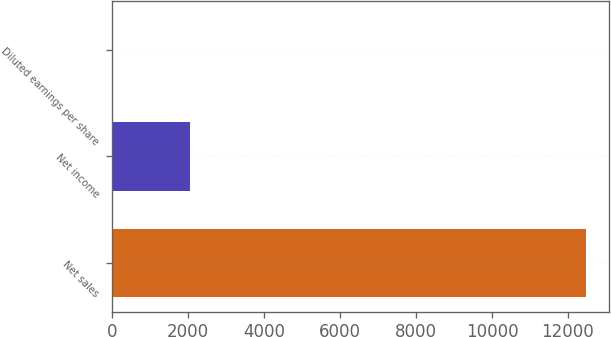<chart> <loc_0><loc_0><loc_500><loc_500><bar_chart><fcel>Net sales<fcel>Net income<fcel>Diluted earnings per share<nl><fcel>12471<fcel>2038<fcel>5.52<nl></chart> 